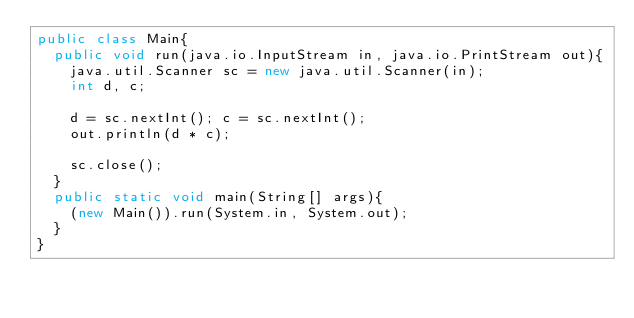Convert code to text. <code><loc_0><loc_0><loc_500><loc_500><_Java_>public class Main{
  public void run(java.io.InputStream in, java.io.PrintStream out){
    java.util.Scanner sc = new java.util.Scanner(in);
    int d, c;

    d = sc.nextInt(); c = sc.nextInt();
    out.println(d * c);

    sc.close();
  }
  public static void main(String[] args){
    (new Main()).run(System.in, System.out);
  }
}</code> 